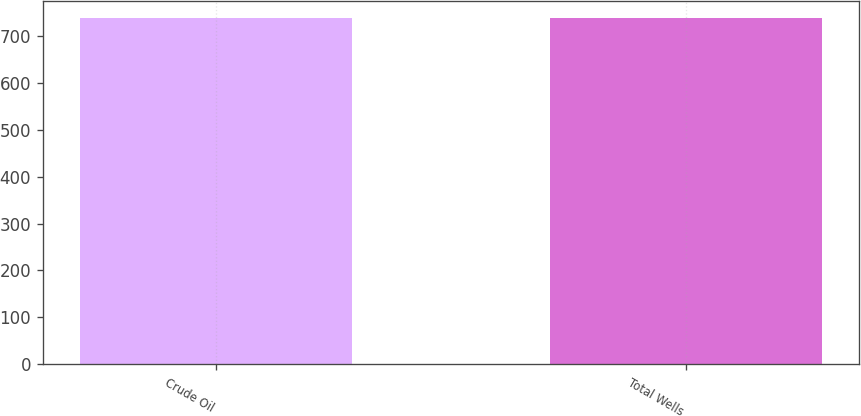Convert chart to OTSL. <chart><loc_0><loc_0><loc_500><loc_500><bar_chart><fcel>Crude Oil<fcel>Total Wells<nl><fcel>738<fcel>738.1<nl></chart> 